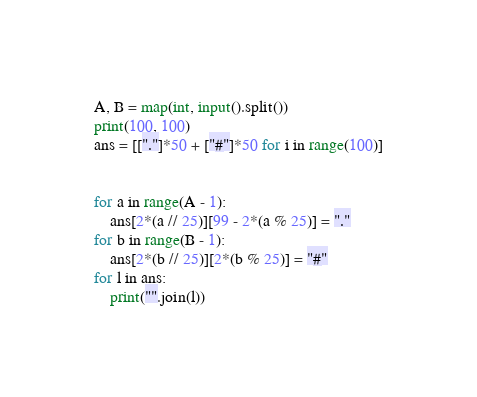<code> <loc_0><loc_0><loc_500><loc_500><_Python_>A, B = map(int, input().split())
print(100, 100)
ans = [["."]*50 + ["#"]*50 for i in range(100)]


for a in range(A - 1):
    ans[2*(a // 25)][99 - 2*(a % 25)] = "."
for b in range(B - 1):
    ans[2*(b // 25)][2*(b % 25)] = "#"
for l in ans:
    print("".join(l))</code> 